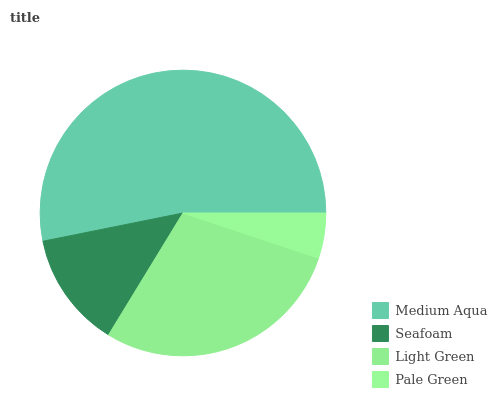Is Pale Green the minimum?
Answer yes or no. Yes. Is Medium Aqua the maximum?
Answer yes or no. Yes. Is Seafoam the minimum?
Answer yes or no. No. Is Seafoam the maximum?
Answer yes or no. No. Is Medium Aqua greater than Seafoam?
Answer yes or no. Yes. Is Seafoam less than Medium Aqua?
Answer yes or no. Yes. Is Seafoam greater than Medium Aqua?
Answer yes or no. No. Is Medium Aqua less than Seafoam?
Answer yes or no. No. Is Light Green the high median?
Answer yes or no. Yes. Is Seafoam the low median?
Answer yes or no. Yes. Is Pale Green the high median?
Answer yes or no. No. Is Light Green the low median?
Answer yes or no. No. 